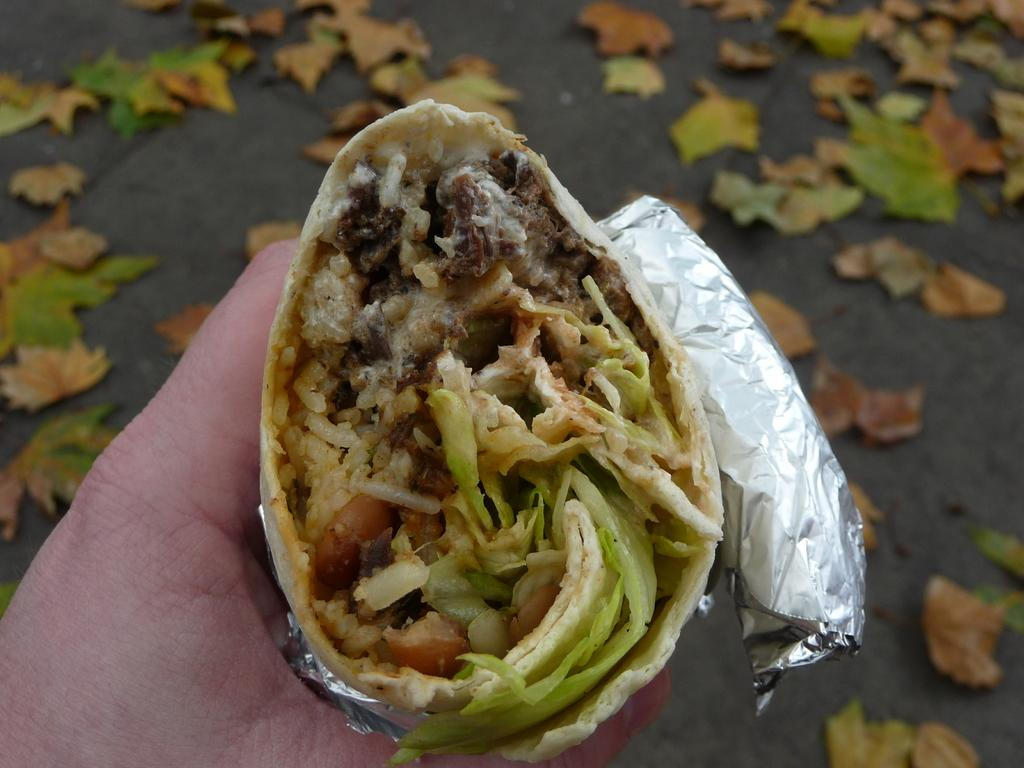What is the main subject of the image? The main subject of the image is a Frankie roll. How is the Frankie roll being held in the image? The Frankie roll is being held in a hand. What can be seen in the background of the image? There are leaves in the background of the image. What type of toothpaste is being used to decorate the Frankie roll in the image? There is no toothpaste present in the image, and the Frankie roll is not being decorated with any substance. Can you see any magical elements in the image? There are no magical elements present in the image; it is a simple image of a Frankie roll being held in a hand with leaves in the background. 